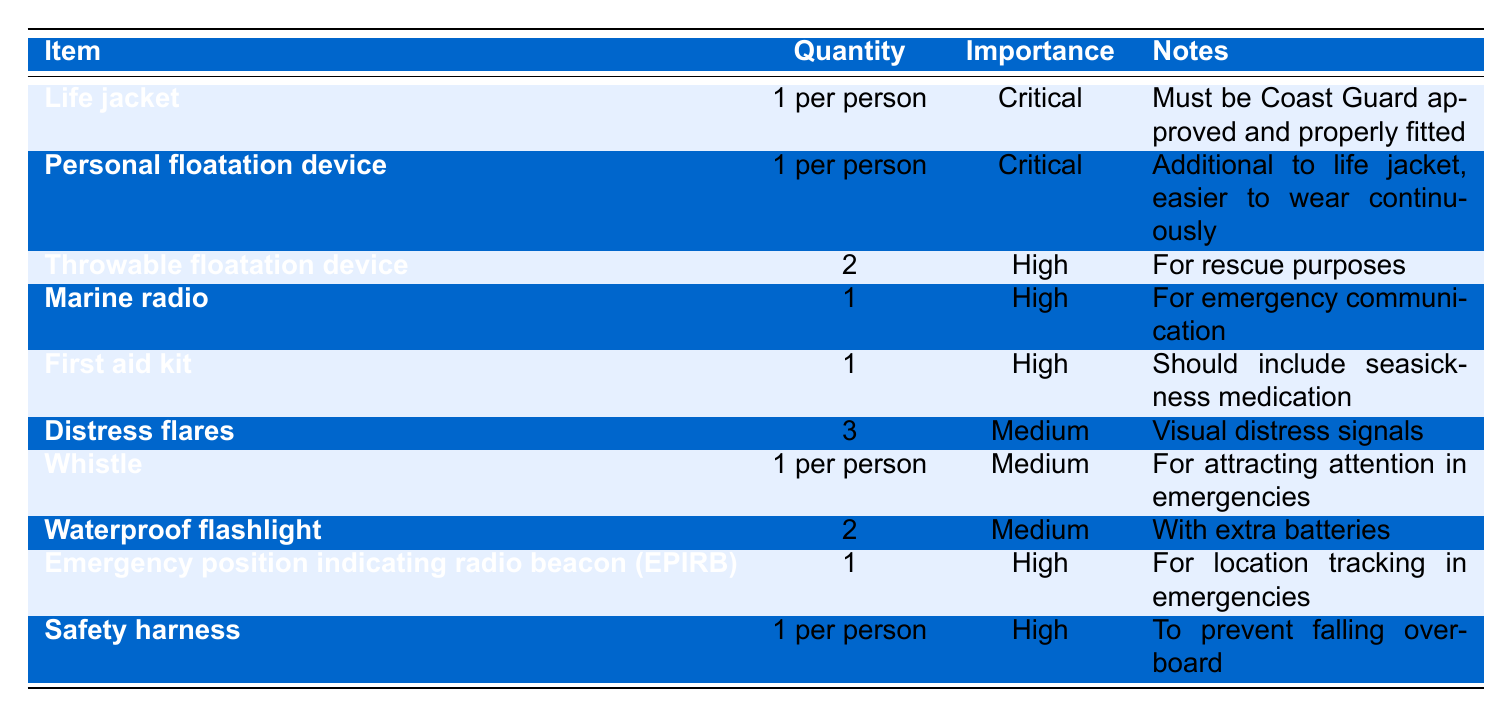What is the quantity of life jackets required? The table specifies that the quantity of life jackets required is "1 per person".
Answer: 1 per person How many throwable flotation devices are needed? The table shows that 2 throwable flotation devices are needed for rescue purposes.
Answer: 2 Is a marine radio considered critical safety equipment? The table indicates that a marine radio has a "High" importance rating, but it is not classified as critical.
Answer: No What is the importance level of the first aid kit? The importance level of the first aid kit is categorized as "High" in the table.
Answer: High How many total personal flotation devices should be on board? Each person requires 1 personal flotation device, in addition to the life jacket; hence, the total number depends on the number of people. Since it's not specified, the answer varies based on the group size.
Answer: Depends on the number of people What equipment has the same importance level as the whistle? The table shows that distress flares and waterproof flashlights also have a "Medium" importance level alongside the whistle.
Answer: Distress flares and waterproof flashlight What is the total quantity of emergency position indicating radio beacons (EPIRB) needed? According to the table, only 1 EPIRB is required for location tracking in emergencies.
Answer: 1 Which item requires the highest quantity based on the checklist? The life jacket and personal flotation device both require "1 per person", but the maximum specific item quantity listed is for "2 throwable flotation devices".
Answer: 2 throwable flotation devices If there are 4 people on the boat, how many total life jackets are needed? For 4 people, you would need 4 life jackets, as the requirement is 1 per person.
Answer: 4 What equipment is specifically noted for keeping someone from falling overboard? The table states that a safety harness is meant to prevent falling overboard, as highlighted in the notes.
Answer: Safety harness 